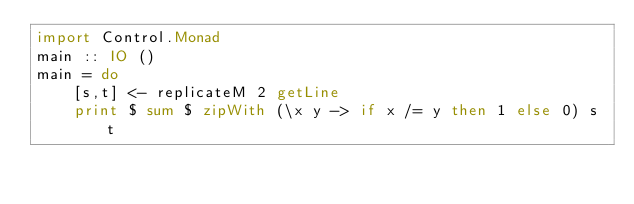<code> <loc_0><loc_0><loc_500><loc_500><_Haskell_>import Control.Monad
main :: IO ()
main = do
    [s,t] <- replicateM 2 getLine
    print $ sum $ zipWith (\x y -> if x /= y then 1 else 0) s t</code> 